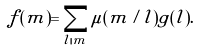Convert formula to latex. <formula><loc_0><loc_0><loc_500><loc_500>f ( m ) = \sum _ { l | m } \mu ( m / l ) g ( l ) .</formula> 